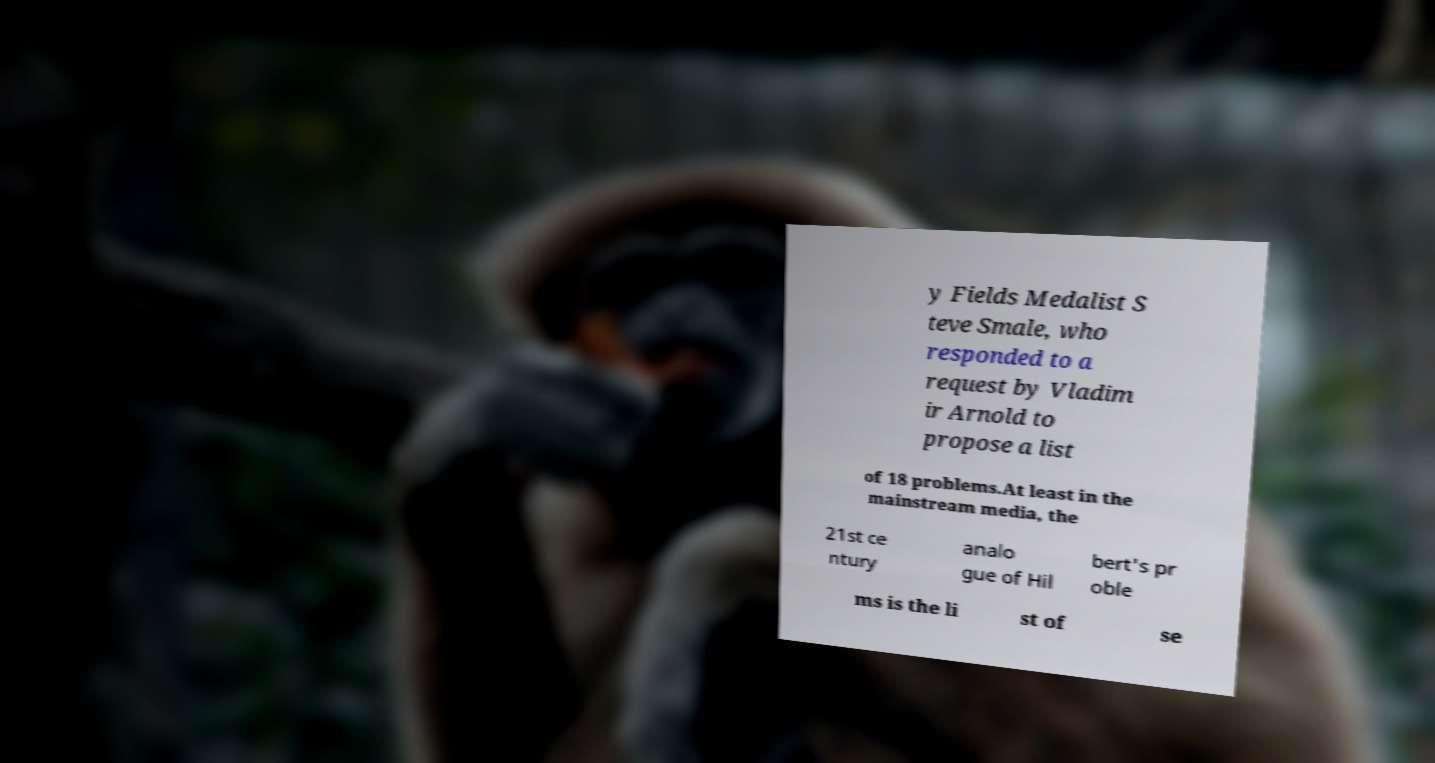Could you assist in decoding the text presented in this image and type it out clearly? y Fields Medalist S teve Smale, who responded to a request by Vladim ir Arnold to propose a list of 18 problems.At least in the mainstream media, the 21st ce ntury analo gue of Hil bert's pr oble ms is the li st of se 